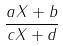<formula> <loc_0><loc_0><loc_500><loc_500>\frac { a X + b } { c X + d }</formula> 